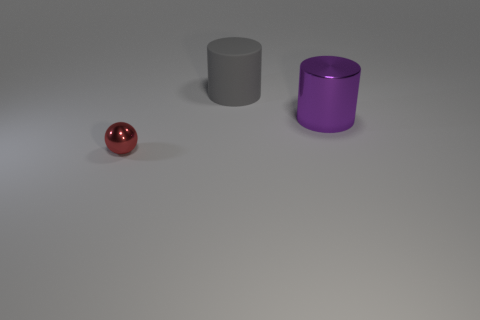Add 2 tiny gray rubber cylinders. How many objects exist? 5 Subtract all cylinders. How many objects are left? 1 Add 1 large rubber objects. How many large rubber objects exist? 2 Subtract 0 red cylinders. How many objects are left? 3 Subtract all small spheres. Subtract all big purple things. How many objects are left? 1 Add 1 large gray objects. How many large gray objects are left? 2 